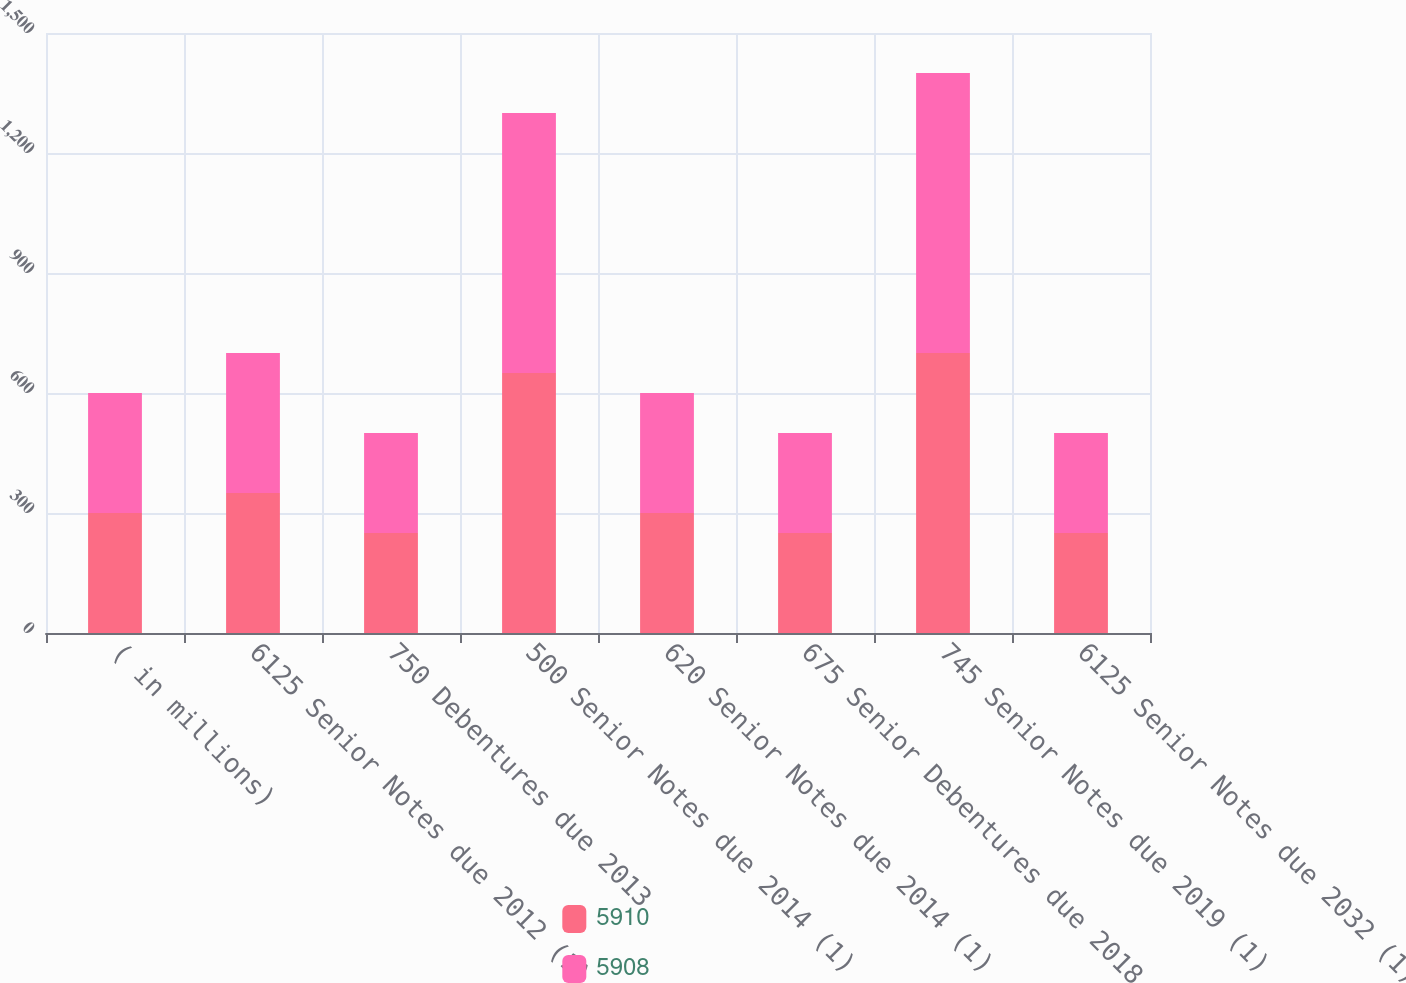Convert chart. <chart><loc_0><loc_0><loc_500><loc_500><stacked_bar_chart><ecel><fcel>( in millions)<fcel>6125 Senior Notes due 2012 (1)<fcel>750 Debentures due 2013<fcel>500 Senior Notes due 2014 (1)<fcel>620 Senior Notes due 2014 (1)<fcel>675 Senior Debentures due 2018<fcel>745 Senior Notes due 2019 (1)<fcel>6125 Senior Notes due 2032 (1)<nl><fcel>5910<fcel>300<fcel>350<fcel>250<fcel>650<fcel>300<fcel>250<fcel>700<fcel>250<nl><fcel>5908<fcel>300<fcel>350<fcel>250<fcel>650<fcel>300<fcel>250<fcel>700<fcel>250<nl></chart> 